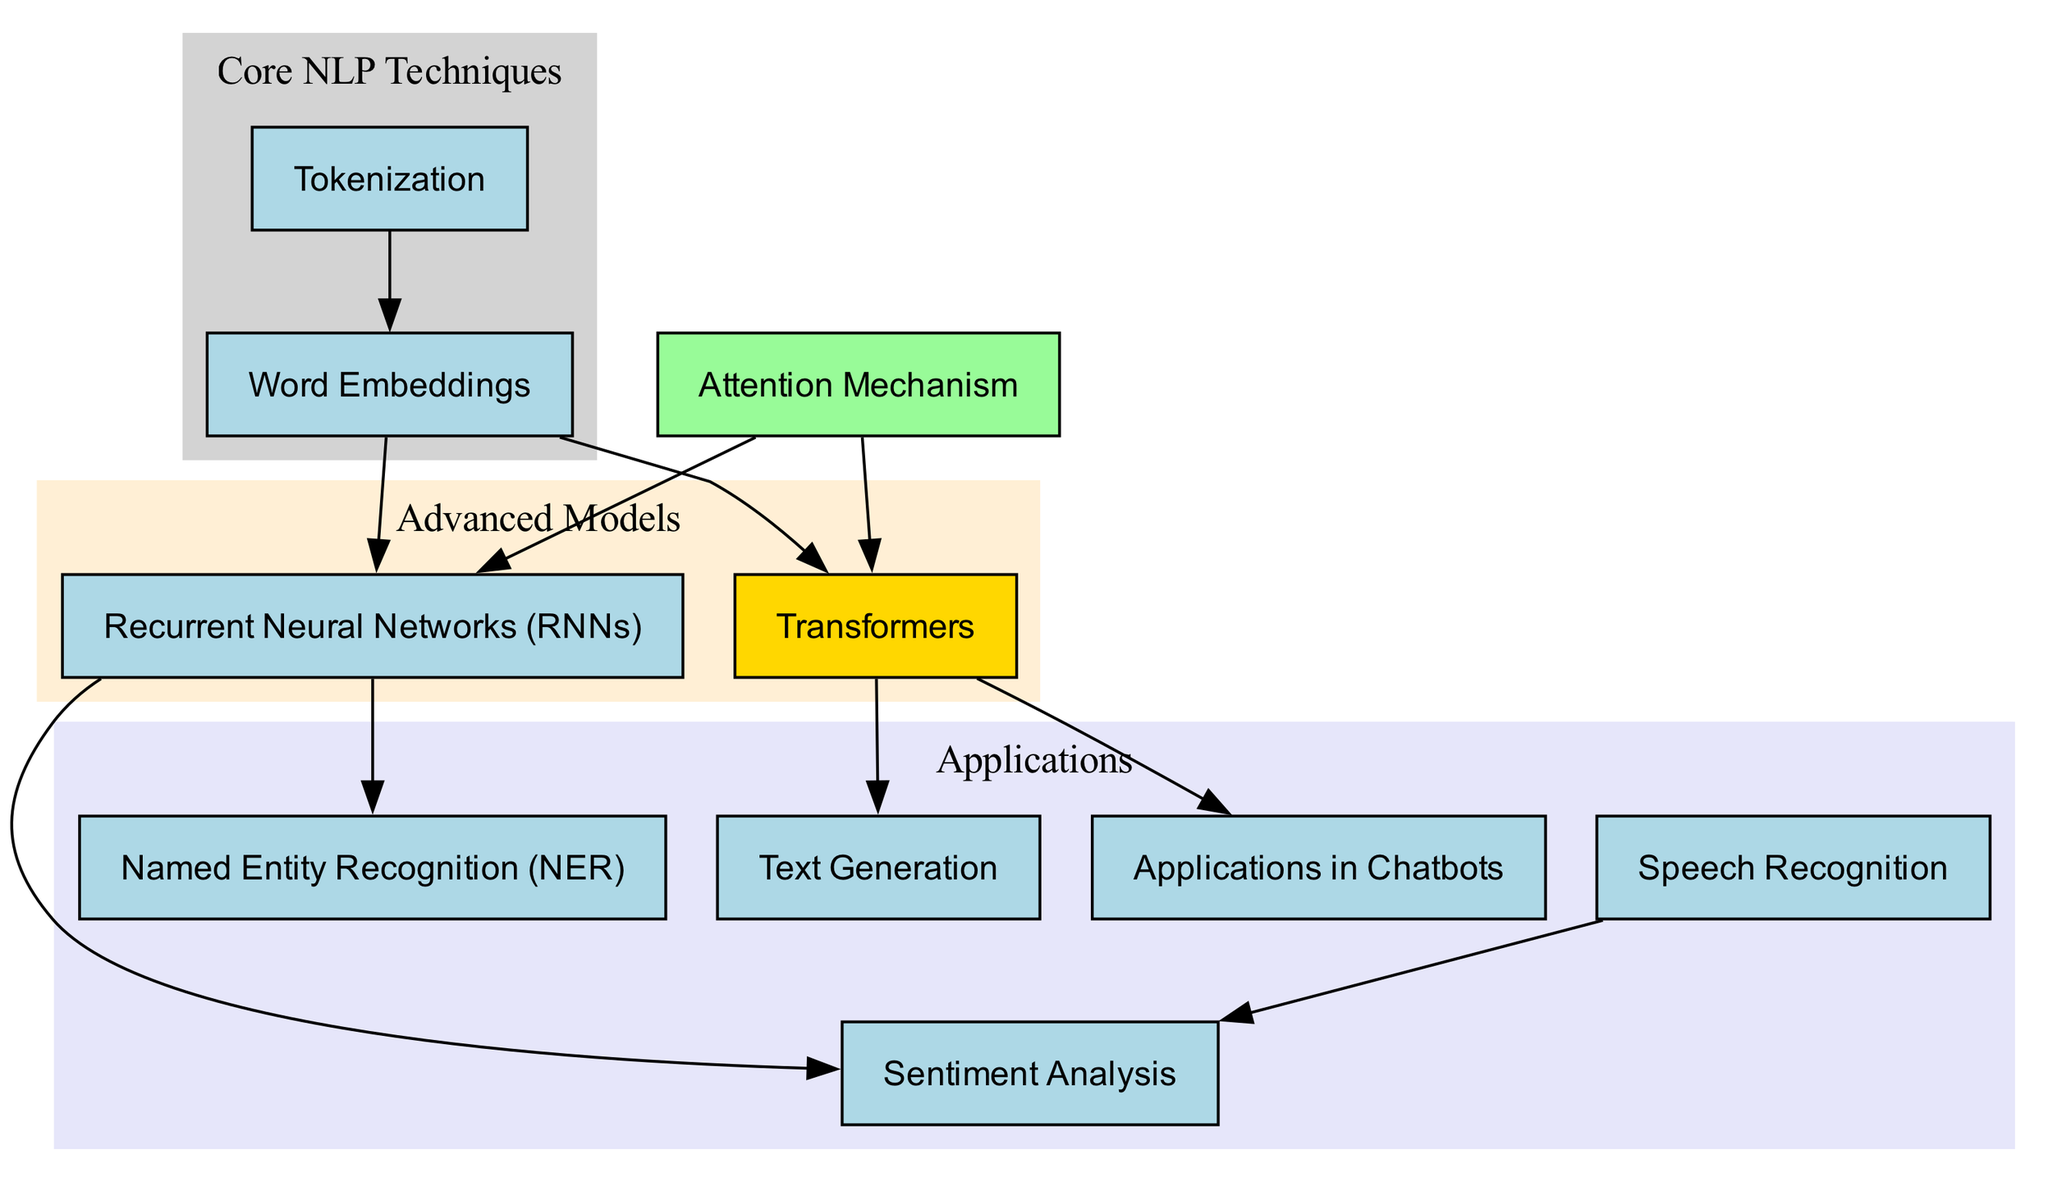What is the total number of nodes in the diagram? The diagram lists various techniques and applications related to NLP and ML. By counting each distinct entry in the nodes section of the data, we find there are ten individual nodes.
Answer: 10 Which technique is directly connected to Named Entity Recognition? In the diagram, there is a directed edge from Recurrent Neural Networks to Named Entity Recognition, indicating a direct relationship.
Answer: Recurrent Neural Networks What application is linked to Speech Recognition? The diagram shows a directed edge from Speech Recognition to Sentiment Analysis, indicating that Speech Recognition is applied in this area.
Answer: Sentiment Analysis Which node highlights a critical technique in the graph? The diagram specifies that the node for Transformers is highlighted in gold, signifying its importance relative to other techniques.
Answer: Transformers How many edges connect Tokenization to other nodes? By reviewing the directed graph connections starting from the Tokenization node, we see it connects to Word Embeddings, resulting in a total of one outgoing edge.
Answer: 1 What is the relationship between Attention Mechanism and Transformers? There are two directed edges stemming from Attention Mechanism to other nodes, specifically to Recurrent Neural Networks and Transformers, demonstrating it influences both.
Answer: Recurrent Neural Networks and Transformers Which application uses Transformers for its implementation? Upon inspection of the directed graph, we observe that Text Generation is the application explicitly linked with the Transformer node.
Answer: Text Generation From which node does Sentiment Analysis receive input? Tracing the connections shows that Sentiment Analysis has a directional input from Recurrent Neural Networks, indicating this as the source technique.
Answer: Recurrent Neural Networks Which models are categorized as Advanced Models in the diagram? The Advanced Models comprise Recurrent Neural Networks and Transformers, as indicated in the subgraph section that clusters these nodes.
Answer: Recurrent Neural Networks and Transformers 